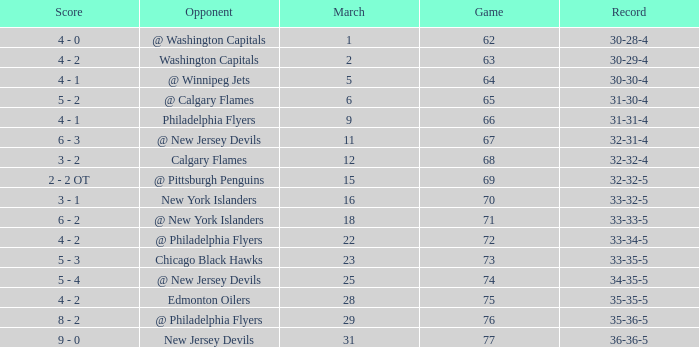How many games ended in a record of 30-28-4, with a March more than 1? 0.0. 